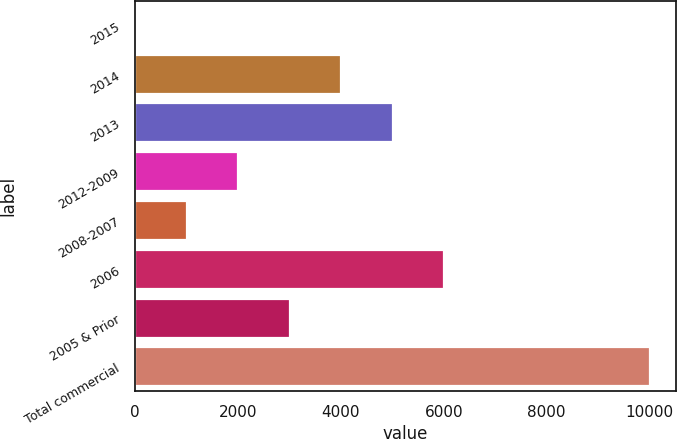<chart> <loc_0><loc_0><loc_500><loc_500><bar_chart><fcel>2015<fcel>2014<fcel>2013<fcel>2012-2009<fcel>2008-2007<fcel>2006<fcel>2005 & Prior<fcel>Total commercial<nl><fcel>1.92<fcel>4004.36<fcel>5004.97<fcel>2003.14<fcel>1002.53<fcel>6005.58<fcel>3003.75<fcel>10008<nl></chart> 